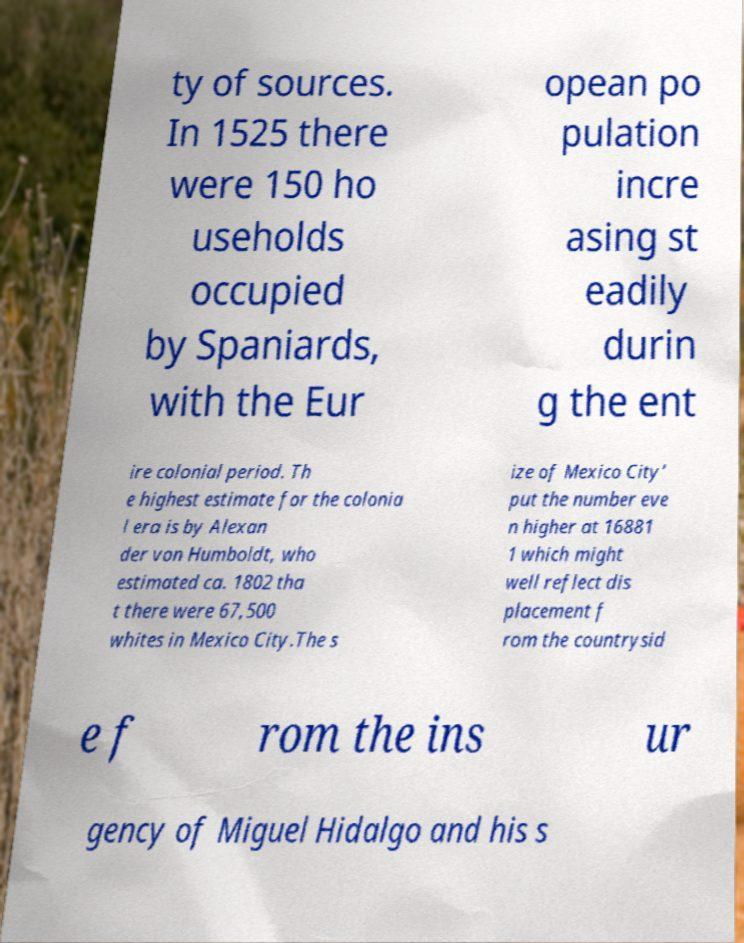Please read and relay the text visible in this image. What does it say? ty of sources. In 1525 there were 150 ho useholds occupied by Spaniards, with the Eur opean po pulation incre asing st eadily durin g the ent ire colonial period. Th e highest estimate for the colonia l era is by Alexan der von Humboldt, who estimated ca. 1802 tha t there were 67,500 whites in Mexico City.The s ize of Mexico City’ put the number eve n higher at 16881 1 which might well reflect dis placement f rom the countrysid e f rom the ins ur gency of Miguel Hidalgo and his s 